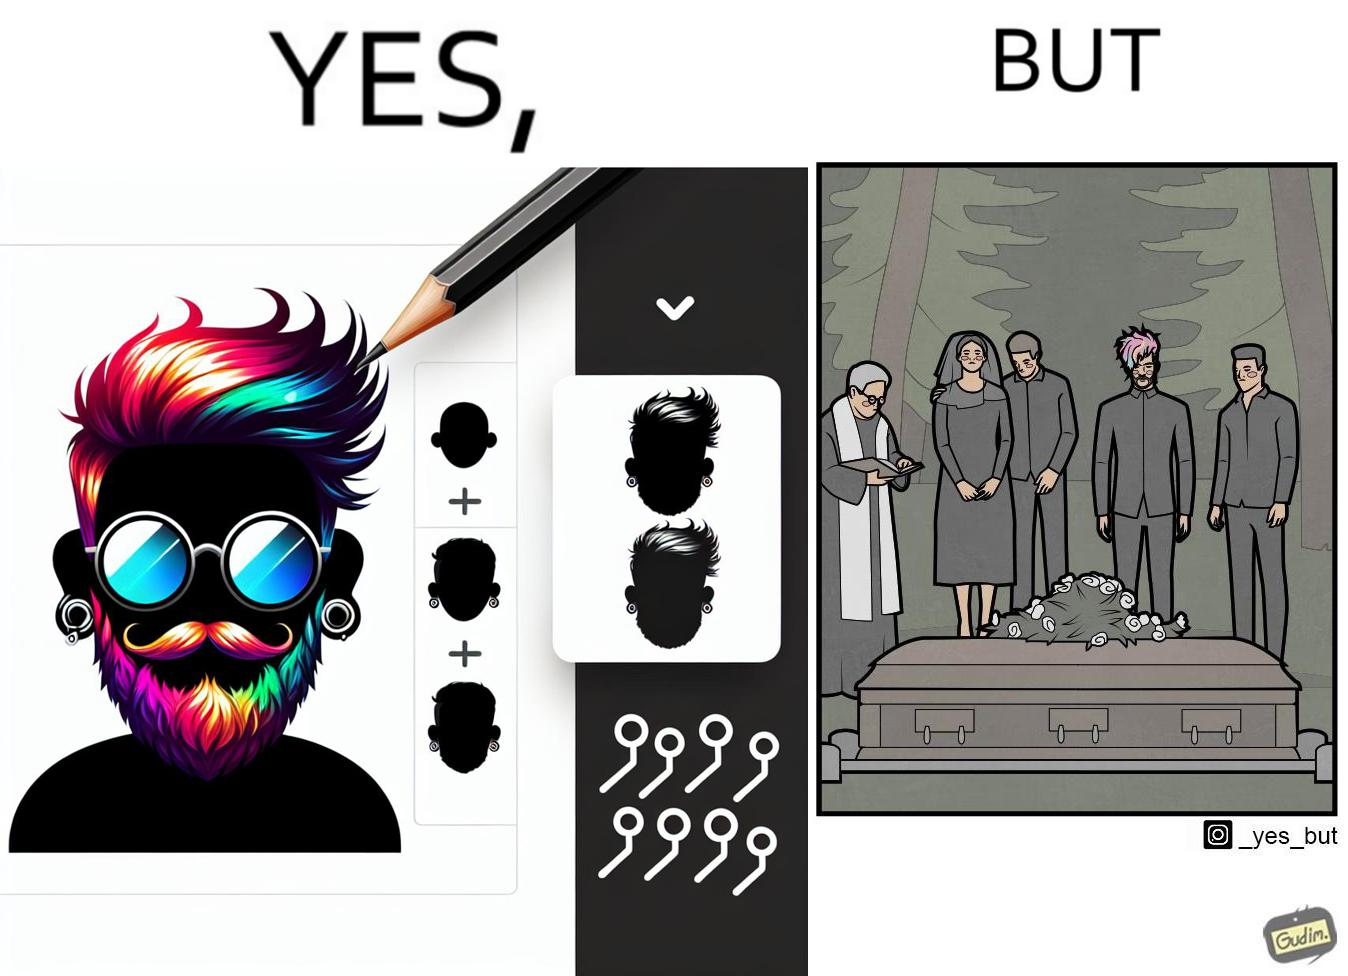What does this image depict? The image is ironic, because in the second image it is shown that a group of people is attending someone's death ceremony but one of them is shown as wrongly dressed for that place in first image, his visual appearances doesn't shows his feeling of mourning 